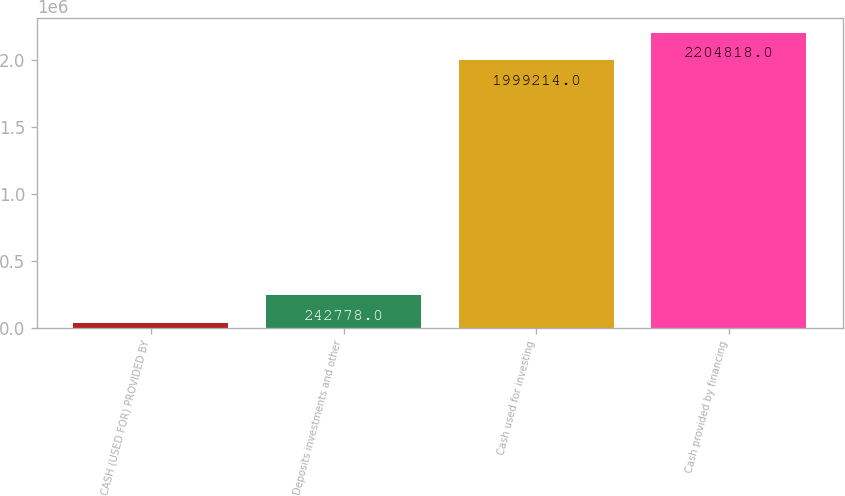Convert chart. <chart><loc_0><loc_0><loc_500><loc_500><bar_chart><fcel>CASH (USED FOR) PROVIDED BY<fcel>Deposits investments and other<fcel>Cash used for investing<fcel>Cash provided by financing<nl><fcel>37174<fcel>242778<fcel>1.99921e+06<fcel>2.20482e+06<nl></chart> 